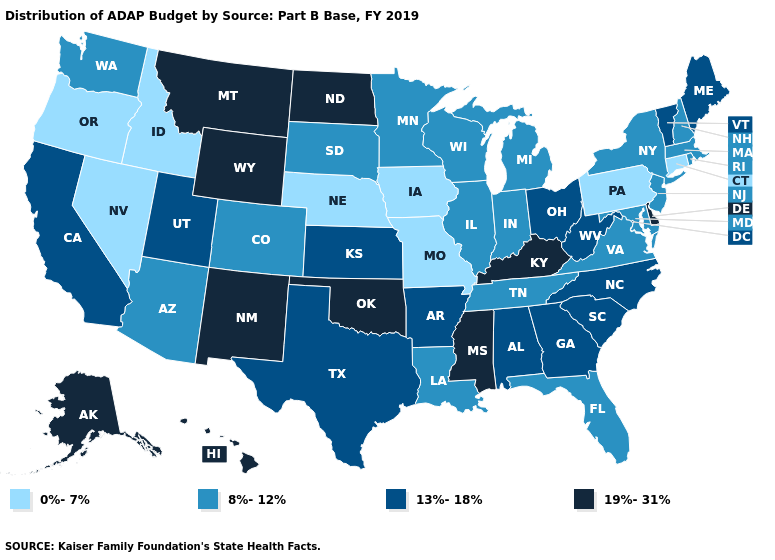Name the states that have a value in the range 0%-7%?
Short answer required. Connecticut, Idaho, Iowa, Missouri, Nebraska, Nevada, Oregon, Pennsylvania. Does Wisconsin have the highest value in the USA?
Concise answer only. No. Among the states that border Georgia , does Tennessee have the lowest value?
Answer briefly. Yes. What is the value of Colorado?
Give a very brief answer. 8%-12%. What is the lowest value in the USA?
Give a very brief answer. 0%-7%. What is the value of Georgia?
Keep it brief. 13%-18%. What is the lowest value in states that border New Hampshire?
Short answer required. 8%-12%. Which states have the highest value in the USA?
Short answer required. Alaska, Delaware, Hawaii, Kentucky, Mississippi, Montana, New Mexico, North Dakota, Oklahoma, Wyoming. Name the states that have a value in the range 13%-18%?
Answer briefly. Alabama, Arkansas, California, Georgia, Kansas, Maine, North Carolina, Ohio, South Carolina, Texas, Utah, Vermont, West Virginia. What is the highest value in the USA?
Write a very short answer. 19%-31%. Does New York have a higher value than Kansas?
Be succinct. No. What is the value of Arkansas?
Be succinct. 13%-18%. Name the states that have a value in the range 0%-7%?
Answer briefly. Connecticut, Idaho, Iowa, Missouri, Nebraska, Nevada, Oregon, Pennsylvania. Name the states that have a value in the range 0%-7%?
Quick response, please. Connecticut, Idaho, Iowa, Missouri, Nebraska, Nevada, Oregon, Pennsylvania. 